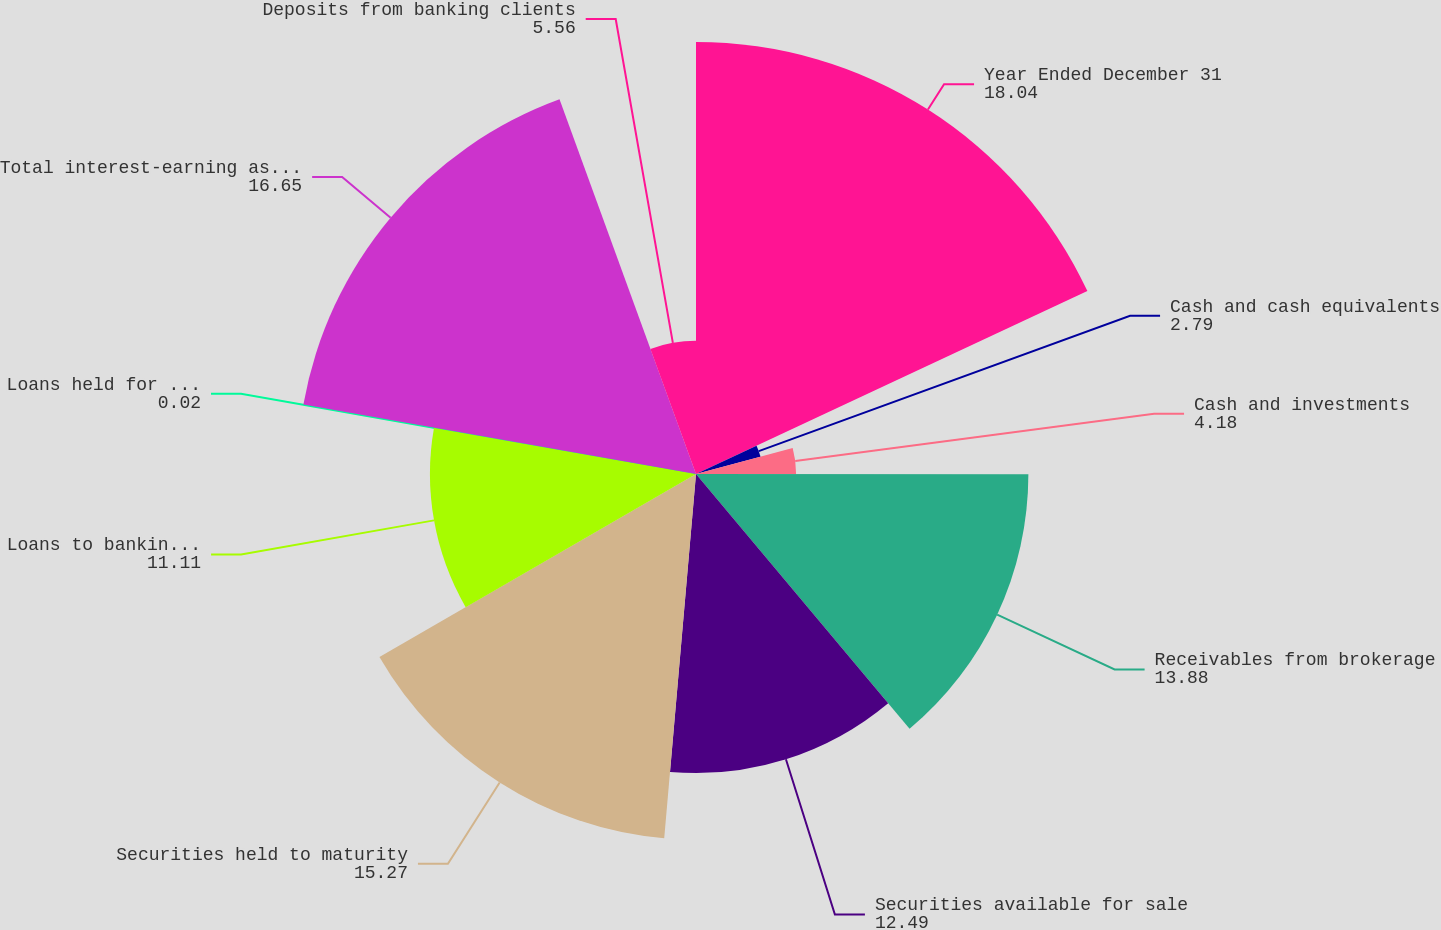Convert chart to OTSL. <chart><loc_0><loc_0><loc_500><loc_500><pie_chart><fcel>Year Ended December 31<fcel>Cash and cash equivalents<fcel>Cash and investments<fcel>Receivables from brokerage<fcel>Securities available for sale<fcel>Securities held to maturity<fcel>Loans to banking clients<fcel>Loans held for sale<fcel>Total interest-earning assets<fcel>Deposits from banking clients<nl><fcel>18.04%<fcel>2.79%<fcel>4.18%<fcel>13.88%<fcel>12.49%<fcel>15.27%<fcel>11.11%<fcel>0.02%<fcel>16.65%<fcel>5.56%<nl></chart> 